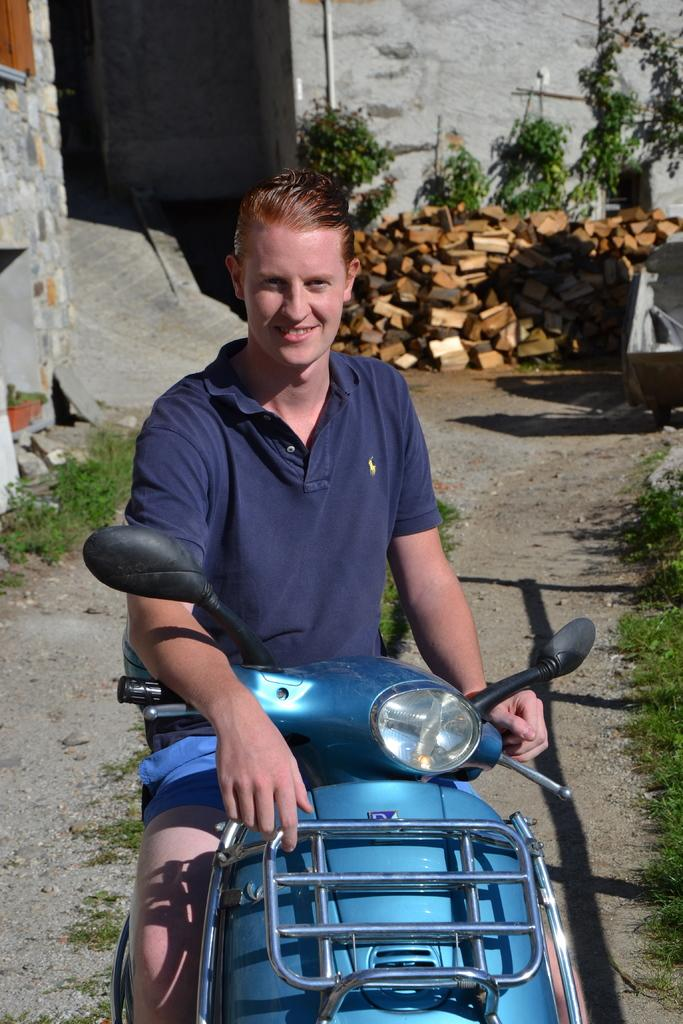What is the man doing in the image? The man is sitting on a motor vehicle. What can be seen in the background of the image? There are plants, wooden blocks, grass, and walls in the background of the image. What type of secretary is working at the system in the image? There is no secretary or system present in the image. 